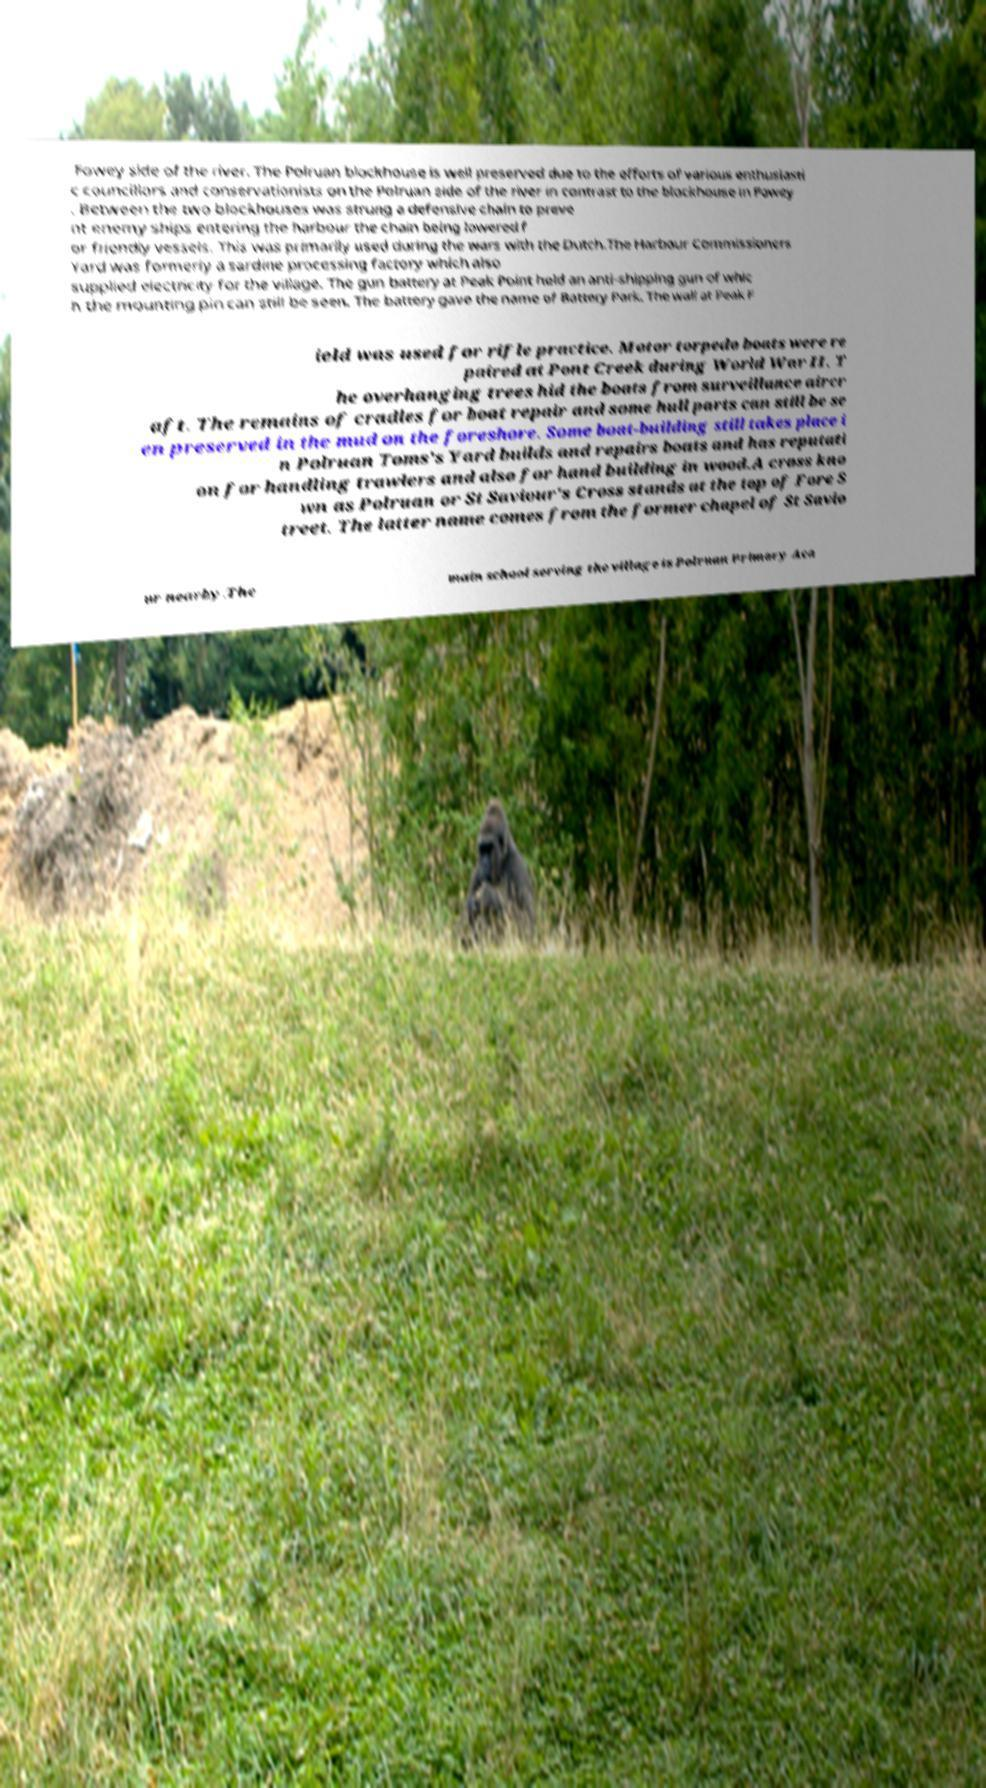Please identify and transcribe the text found in this image. Fowey side of the river. The Polruan blockhouse is well preserved due to the efforts of various enthusiasti c councillors and conservationists on the Polruan side of the river in contrast to the blockhouse in Fowey . Between the two blockhouses was strung a defensive chain to preve nt enemy ships entering the harbour the chain being lowered f or friendly vessels. This was primarily used during the wars with the Dutch.The Harbour Commissioners Yard was formerly a sardine processing factory which also supplied electricity for the village. The gun battery at Peak Point held an anti-shipping gun of whic h the mounting pin can still be seen. The battery gave the name of Battery Park. The wall at Peak F ield was used for rifle practice. Motor torpedo boats were re paired at Pont Creek during World War II. T he overhanging trees hid the boats from surveillance aircr aft. The remains of cradles for boat repair and some hull parts can still be se en preserved in the mud on the foreshore. Some boat-building still takes place i n Polruan Toms's Yard builds and repairs boats and has reputati on for handling trawlers and also for hand building in wood.A cross kno wn as Polruan or St Saviour's Cross stands at the top of Fore S treet. The latter name comes from the former chapel of St Savio ur nearby.The main school serving the village is Polruan Primary Aca 